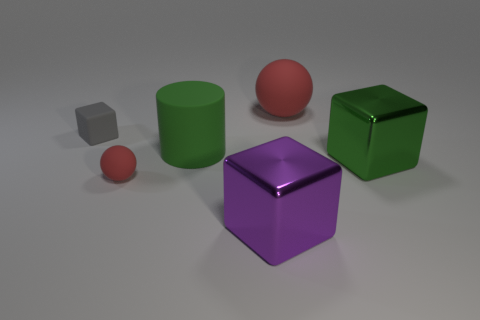Add 2 tiny rubber things. How many objects exist? 8 Subtract all balls. How many objects are left? 4 Subtract all big purple shiny cylinders. Subtract all tiny rubber blocks. How many objects are left? 5 Add 1 small rubber cubes. How many small rubber cubes are left? 2 Add 3 red matte balls. How many red matte balls exist? 5 Subtract 0 yellow spheres. How many objects are left? 6 